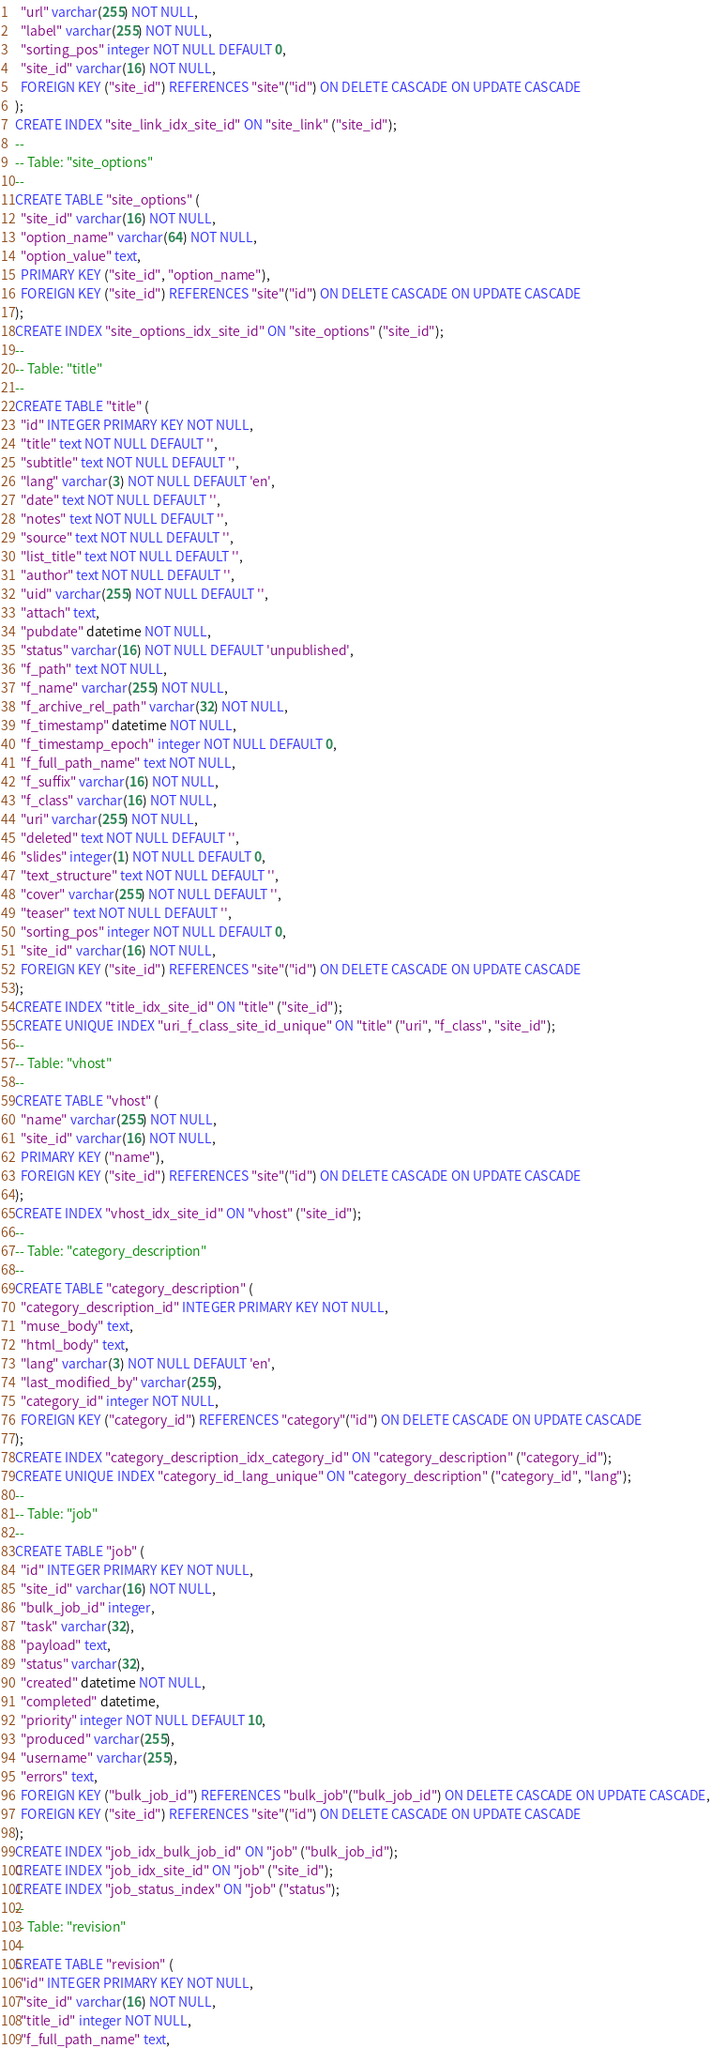Convert code to text. <code><loc_0><loc_0><loc_500><loc_500><_SQL_>  "url" varchar(255) NOT NULL,
  "label" varchar(255) NOT NULL,
  "sorting_pos" integer NOT NULL DEFAULT 0,
  "site_id" varchar(16) NOT NULL,
  FOREIGN KEY ("site_id") REFERENCES "site"("id") ON DELETE CASCADE ON UPDATE CASCADE
);
CREATE INDEX "site_link_idx_site_id" ON "site_link" ("site_id");
--
-- Table: "site_options"
--
CREATE TABLE "site_options" (
  "site_id" varchar(16) NOT NULL,
  "option_name" varchar(64) NOT NULL,
  "option_value" text,
  PRIMARY KEY ("site_id", "option_name"),
  FOREIGN KEY ("site_id") REFERENCES "site"("id") ON DELETE CASCADE ON UPDATE CASCADE
);
CREATE INDEX "site_options_idx_site_id" ON "site_options" ("site_id");
--
-- Table: "title"
--
CREATE TABLE "title" (
  "id" INTEGER PRIMARY KEY NOT NULL,
  "title" text NOT NULL DEFAULT '',
  "subtitle" text NOT NULL DEFAULT '',
  "lang" varchar(3) NOT NULL DEFAULT 'en',
  "date" text NOT NULL DEFAULT '',
  "notes" text NOT NULL DEFAULT '',
  "source" text NOT NULL DEFAULT '',
  "list_title" text NOT NULL DEFAULT '',
  "author" text NOT NULL DEFAULT '',
  "uid" varchar(255) NOT NULL DEFAULT '',
  "attach" text,
  "pubdate" datetime NOT NULL,
  "status" varchar(16) NOT NULL DEFAULT 'unpublished',
  "f_path" text NOT NULL,
  "f_name" varchar(255) NOT NULL,
  "f_archive_rel_path" varchar(32) NOT NULL,
  "f_timestamp" datetime NOT NULL,
  "f_timestamp_epoch" integer NOT NULL DEFAULT 0,
  "f_full_path_name" text NOT NULL,
  "f_suffix" varchar(16) NOT NULL,
  "f_class" varchar(16) NOT NULL,
  "uri" varchar(255) NOT NULL,
  "deleted" text NOT NULL DEFAULT '',
  "slides" integer(1) NOT NULL DEFAULT 0,
  "text_structure" text NOT NULL DEFAULT '',
  "cover" varchar(255) NOT NULL DEFAULT '',
  "teaser" text NOT NULL DEFAULT '',
  "sorting_pos" integer NOT NULL DEFAULT 0,
  "site_id" varchar(16) NOT NULL,
  FOREIGN KEY ("site_id") REFERENCES "site"("id") ON DELETE CASCADE ON UPDATE CASCADE
);
CREATE INDEX "title_idx_site_id" ON "title" ("site_id");
CREATE UNIQUE INDEX "uri_f_class_site_id_unique" ON "title" ("uri", "f_class", "site_id");
--
-- Table: "vhost"
--
CREATE TABLE "vhost" (
  "name" varchar(255) NOT NULL,
  "site_id" varchar(16) NOT NULL,
  PRIMARY KEY ("name"),
  FOREIGN KEY ("site_id") REFERENCES "site"("id") ON DELETE CASCADE ON UPDATE CASCADE
);
CREATE INDEX "vhost_idx_site_id" ON "vhost" ("site_id");
--
-- Table: "category_description"
--
CREATE TABLE "category_description" (
  "category_description_id" INTEGER PRIMARY KEY NOT NULL,
  "muse_body" text,
  "html_body" text,
  "lang" varchar(3) NOT NULL DEFAULT 'en',
  "last_modified_by" varchar(255),
  "category_id" integer NOT NULL,
  FOREIGN KEY ("category_id") REFERENCES "category"("id") ON DELETE CASCADE ON UPDATE CASCADE
);
CREATE INDEX "category_description_idx_category_id" ON "category_description" ("category_id");
CREATE UNIQUE INDEX "category_id_lang_unique" ON "category_description" ("category_id", "lang");
--
-- Table: "job"
--
CREATE TABLE "job" (
  "id" INTEGER PRIMARY KEY NOT NULL,
  "site_id" varchar(16) NOT NULL,
  "bulk_job_id" integer,
  "task" varchar(32),
  "payload" text,
  "status" varchar(32),
  "created" datetime NOT NULL,
  "completed" datetime,
  "priority" integer NOT NULL DEFAULT 10,
  "produced" varchar(255),
  "username" varchar(255),
  "errors" text,
  FOREIGN KEY ("bulk_job_id") REFERENCES "bulk_job"("bulk_job_id") ON DELETE CASCADE ON UPDATE CASCADE,
  FOREIGN KEY ("site_id") REFERENCES "site"("id") ON DELETE CASCADE ON UPDATE CASCADE
);
CREATE INDEX "job_idx_bulk_job_id" ON "job" ("bulk_job_id");
CREATE INDEX "job_idx_site_id" ON "job" ("site_id");
CREATE INDEX "job_status_index" ON "job" ("status");
--
-- Table: "revision"
--
CREATE TABLE "revision" (
  "id" INTEGER PRIMARY KEY NOT NULL,
  "site_id" varchar(16) NOT NULL,
  "title_id" integer NOT NULL,
  "f_full_path_name" text,</code> 